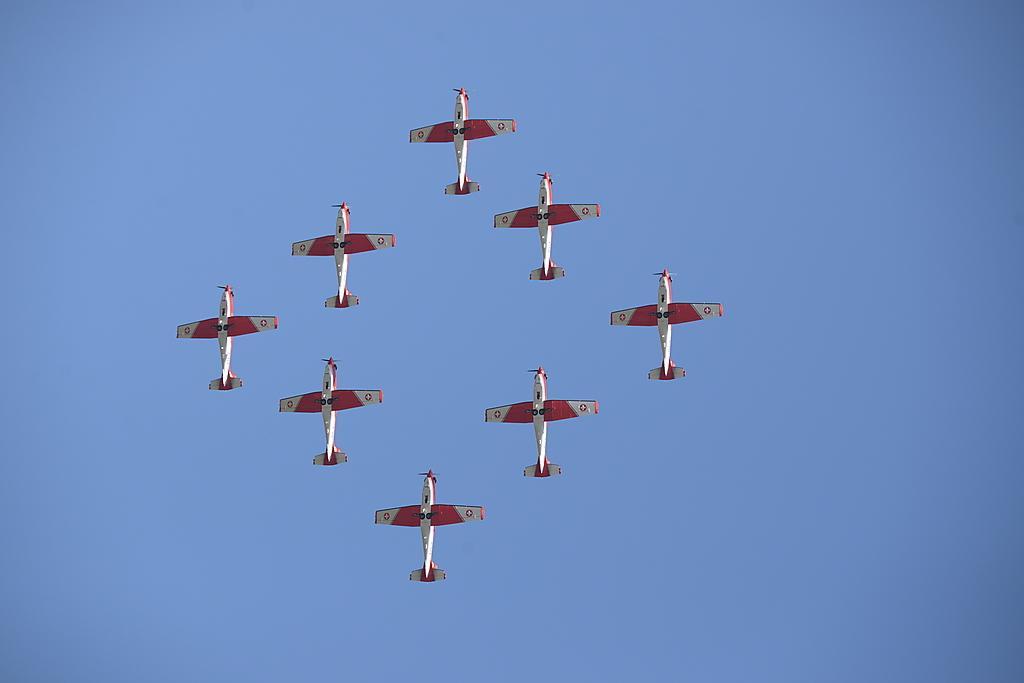Describe this image in one or two sentences. In the center of the image we can see a few airplanes, which are in red and white color. In the background, we can see the sky. 